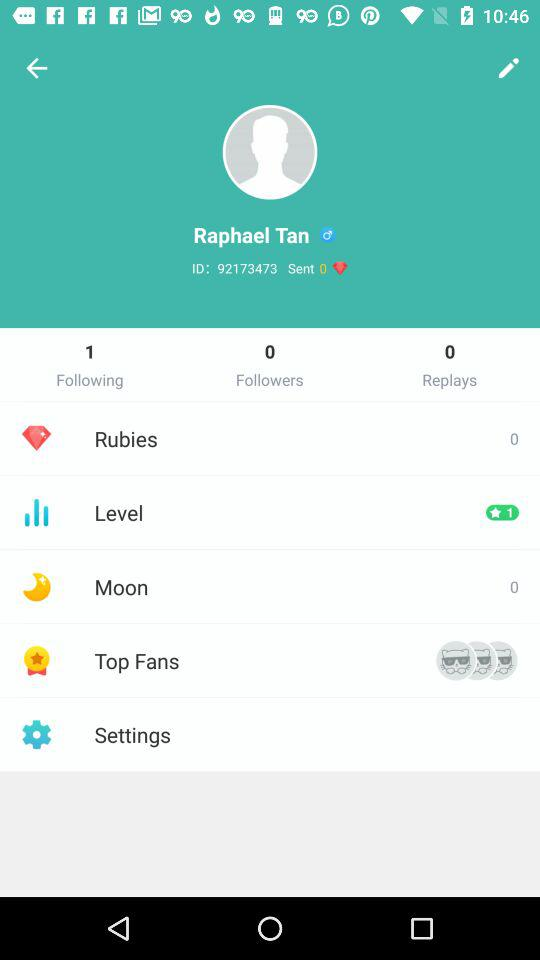How many followers are there? There are 0 followers. 